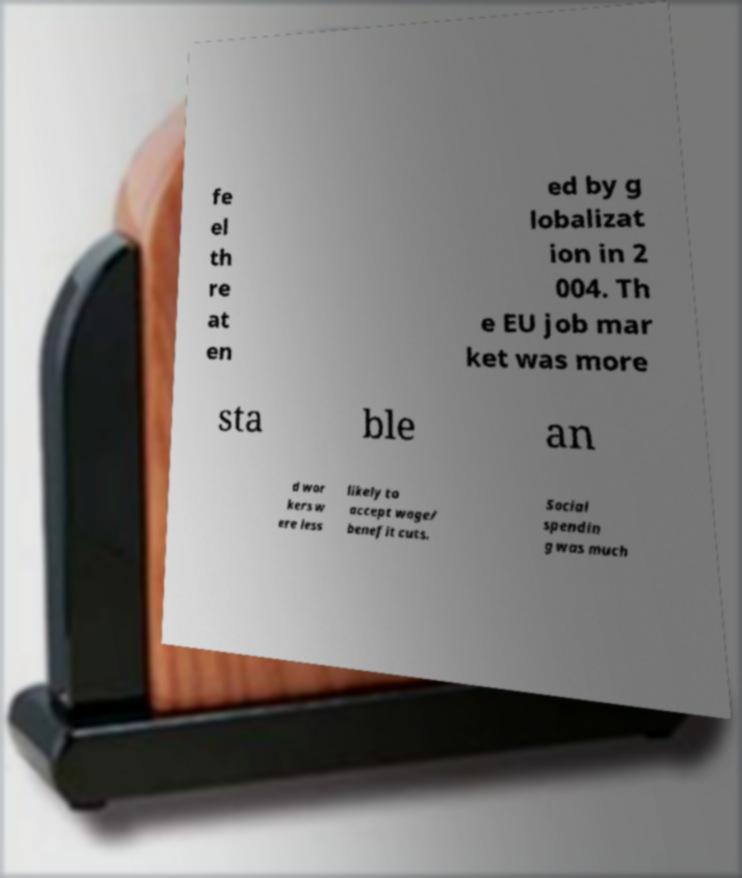Please identify and transcribe the text found in this image. fe el th re at en ed by g lobalizat ion in 2 004. Th e EU job mar ket was more sta ble an d wor kers w ere less likely to accept wage/ benefit cuts. Social spendin g was much 